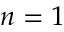<formula> <loc_0><loc_0><loc_500><loc_500>n = 1</formula> 